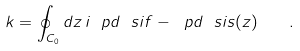Convert formula to latex. <formula><loc_0><loc_0><loc_500><loc_500>k = \oint _ { C _ { 0 } } d z \, i \ p d \ s i f - \ p d \ s i s ( z ) \quad .</formula> 